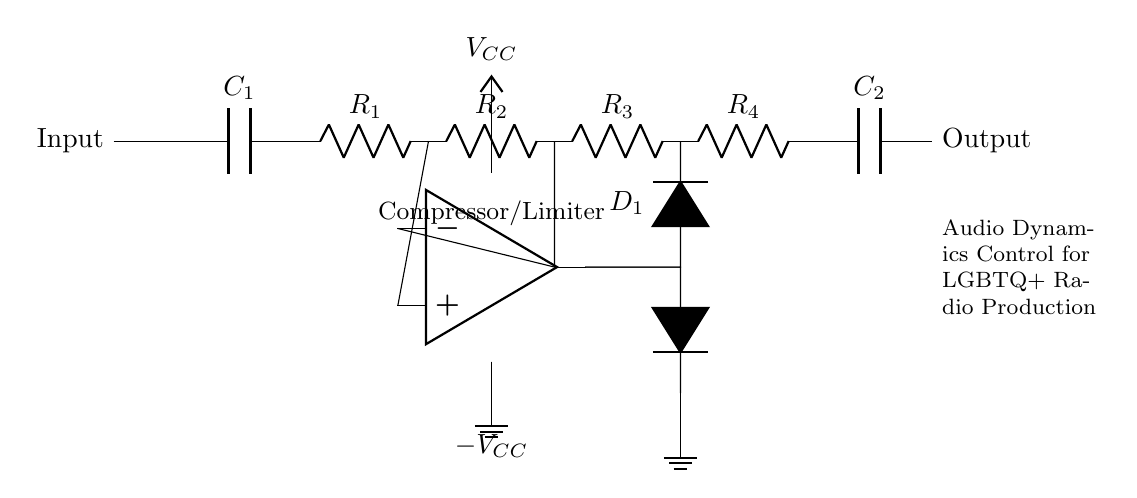What is the purpose of the capacitor C1? Capacitor C1 is used to couple the input signal, allowing AC signals to pass while blocking DC components. This is a common application in audio circuits to maintain signal integrity.
Answer: Coupling What type of circuit is this? The circuit is a compressor/limiter, which dynamically controls audio levels by reducing the gain of loud signals and preventing clipping. This helps in maintaining a consistent audio level.
Answer: Compressor/Limiter How many resistors are in the circuit? There are four resistors labeled as R1, R2, R3, and R4 that form part of the circuit for various functions including setting gain and frequency response.
Answer: Four What is connected to the output? The final output is connected through a capacitor C2 which further filters the audio signal before sending it to the output stage. This helps to smooth the output waveform.
Answer: Capacitor C2 What types of diodes are used in this circuit? The circuit uses two signal diodes, one of which is labeled D1. These diodes are used for clipping the signal at the output stage to prevent distortion.
Answer: Signal diodes How is the operational amplifier powered? The operational amplifier is powered by two supply voltages: VCC for positive supply and -VCC for negative supply, allowing it to operate properly in an audio signal processing role.
Answer: VCC and -VCC 